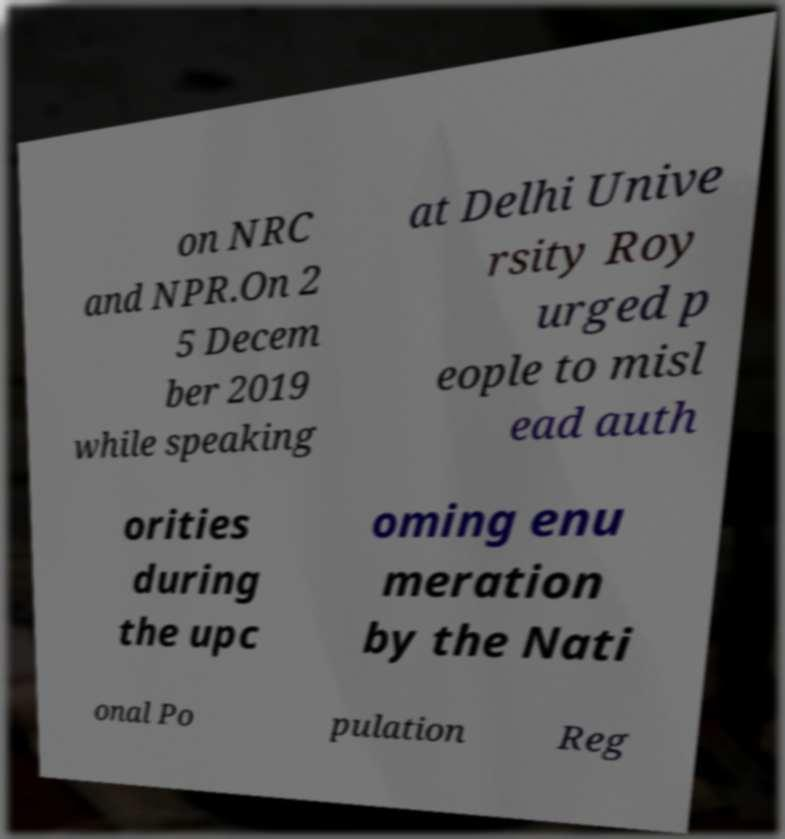Can you accurately transcribe the text from the provided image for me? on NRC and NPR.On 2 5 Decem ber 2019 while speaking at Delhi Unive rsity Roy urged p eople to misl ead auth orities during the upc oming enu meration by the Nati onal Po pulation Reg 